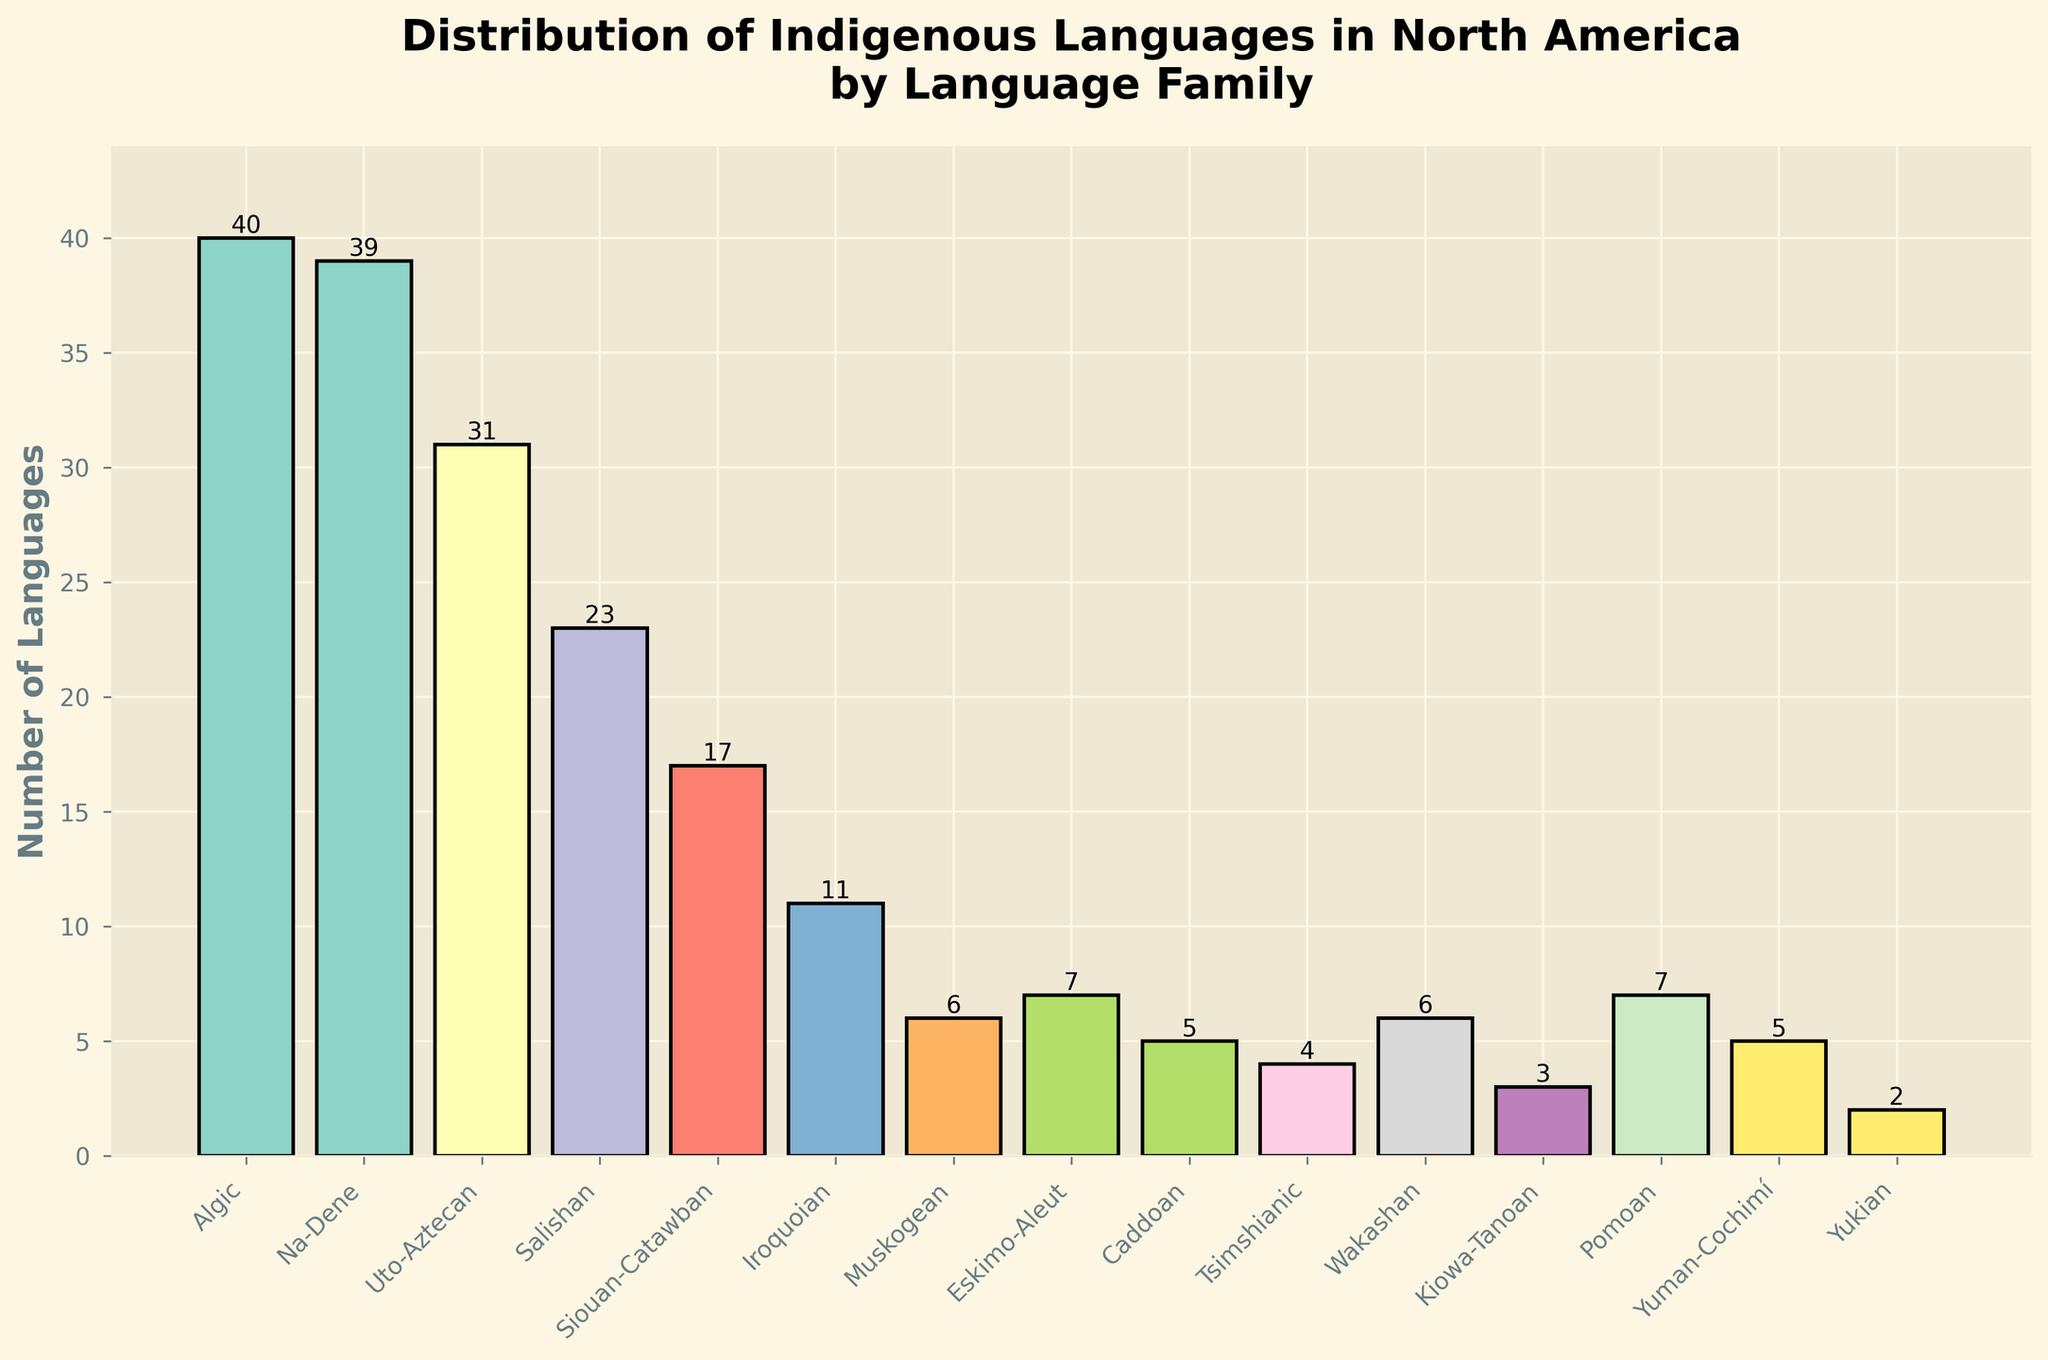Which language family has the highest number of languages? Look at the bar representing the language families and identify the one with the highest bar. "Algic" has a bar reaching 40, the highest number.
Answer: Algic Which language family has the lowest number of languages? Look at the bars representing the language families and identify the one with the shortest bar. "Yukian" has the shortest bar with 2 languages.
Answer: Yukian How many more languages does the Algic family have compared to the Muskogean family? Algic has 40 languages, and Muskogean has 6 languages. Subtract the number of Muskogean languages from the number of Algic languages (40 - 6 = 34).
Answer: 34 What is the total number of languages spoken according to the figure? Sum up the number of languages for all language families (40 + 39 + 31 + 23 + 17 + 11 + 6 + 7 + 5 + 4 + 6 + 3 + 7 + 5 + 2 = 206).
Answer: 206 Which two language families have an equal number of languages? Look for bars of equal height. "Muskogean" and "Wakashan" both have bars reaching 6, indicating an equal number of languages.
Answer: Muskogean and Wakashan Compare the number of languages in the Eskimo-Aleut family to the Caddoan family. Which has more, and by how much? Eskimo-Aleut has 7 languages, and Caddoan has 5 languages. Subtract the number of Caddoan languages from the number of Eskimo-Aleut languages (7 - 5 = 2).
Answer: Eskimo-Aleut by 2 What is the average number of languages per family? Sum up the number of languages for all language families and divide by the number of families (206 / 15 = approximately 13.73).
Answer: Approximately 13.73 Which language family has the third highest number of languages? Identify the third tallest bar. The tallest bars are Algic (40), Na-Dene (39), and Uto-Aztecan (31), making Uto-Aztecan third.
Answer: Uto-Aztecan What is the combined number of languages in the Siouan-Catawban and Iroquoian families? Add the number of languages in Siouan-Catawban (17) and Iroquoian (11) families (17 + 11 = 28).
Answer: 28 How does the number of languages in the Salishan family compare to the number in the Caddoan family? Salishan has 23 languages, and Caddoan has 5 languages. Salishan has more languages.
Answer: Salishan has more languages 